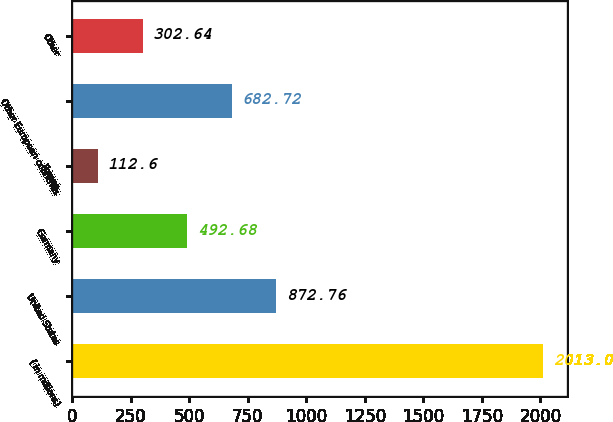<chart> <loc_0><loc_0><loc_500><loc_500><bar_chart><fcel>( in millions)<fcel>United States<fcel>Germany<fcel>France<fcel>Other European countries<fcel>Other<nl><fcel>2013<fcel>872.76<fcel>492.68<fcel>112.6<fcel>682.72<fcel>302.64<nl></chart> 